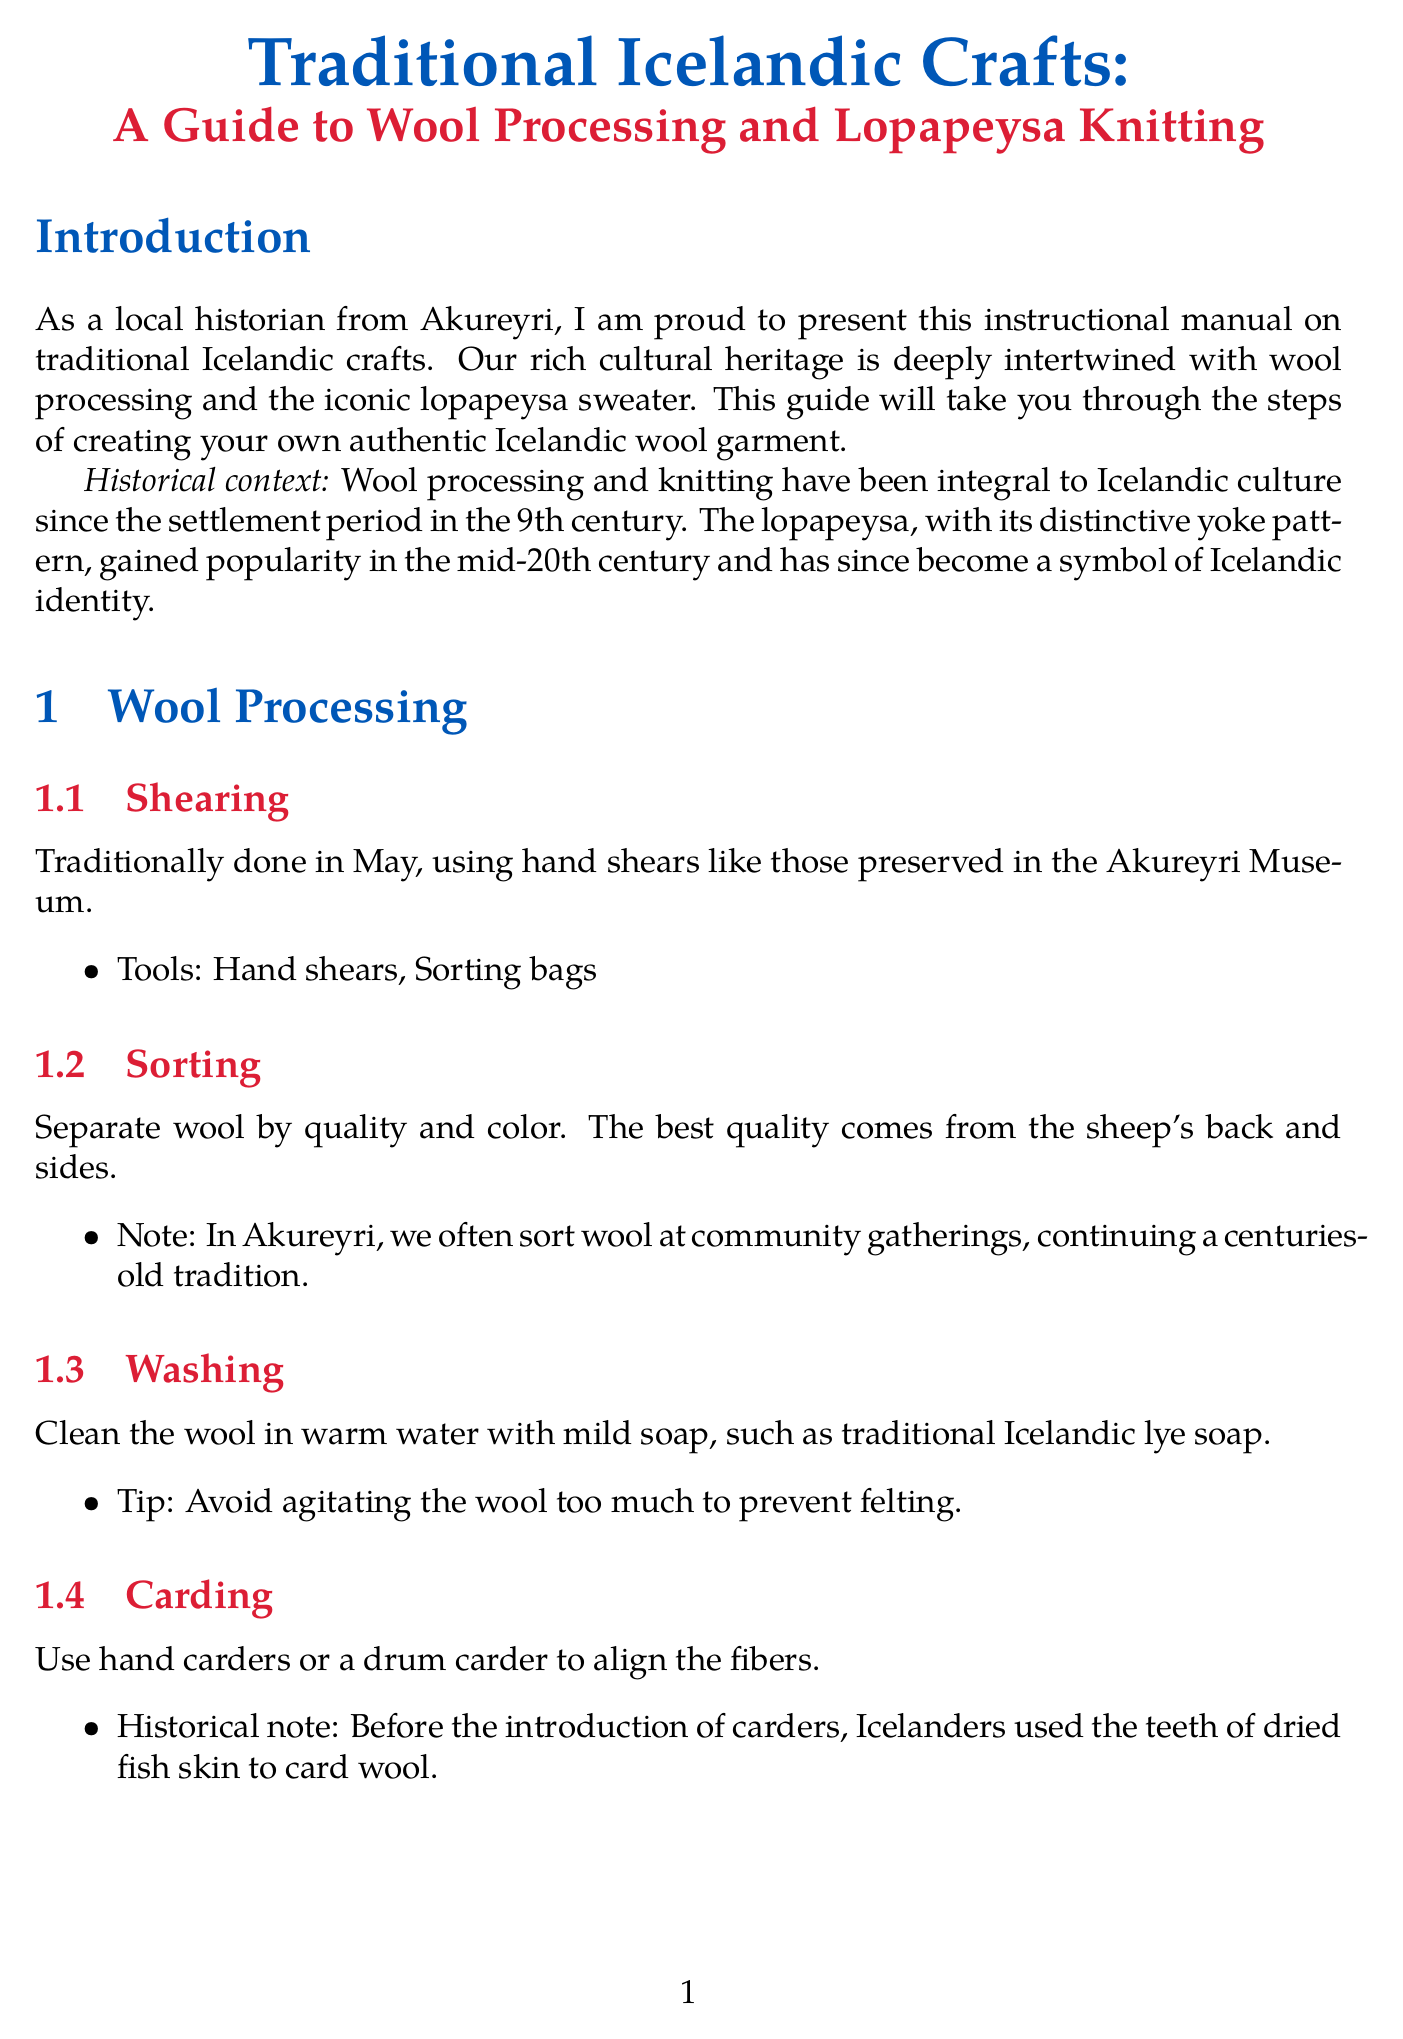what month is traditionally designated for shearing? The document states that shearing is traditionally done in May.
Answer: May what tool is used for washing wool? The washing step describes using mild soap, specifically traditional Icelandic lye soap.
Answer: lye soap what type of wool is used for lopapeysa? The materials section lists Icelandic wool (lopi) as the primary type of wool used.
Answer: Icelandic wool (lopi) how many knitting needle sizes are mentioned? The materials section lists two sizes of circular knitting needles: 4.5mm and 5mm.
Answer: two what is a popular motif for lopapeysa patterns? The document provides examples of popular motifs, including snowflakes.
Answer: snowflakes how can you finish the neckband according to local variation? The neckband section indicates that some knitters in Akureyri add a small hidden pocket.
Answer: a small hidden pocket what is crucial for setting the final shape of the sweater? The finishing step mentions that blocking is crucial for evening out the stitches and setting the final shape.
Answer: blocking what is the annual event mentioned for learning about Icelandic wool crafts? The conclusion invites readers to visit the Akureyri Knitting Festival held annually in June.
Answer: Akureyri Knitting Festival 